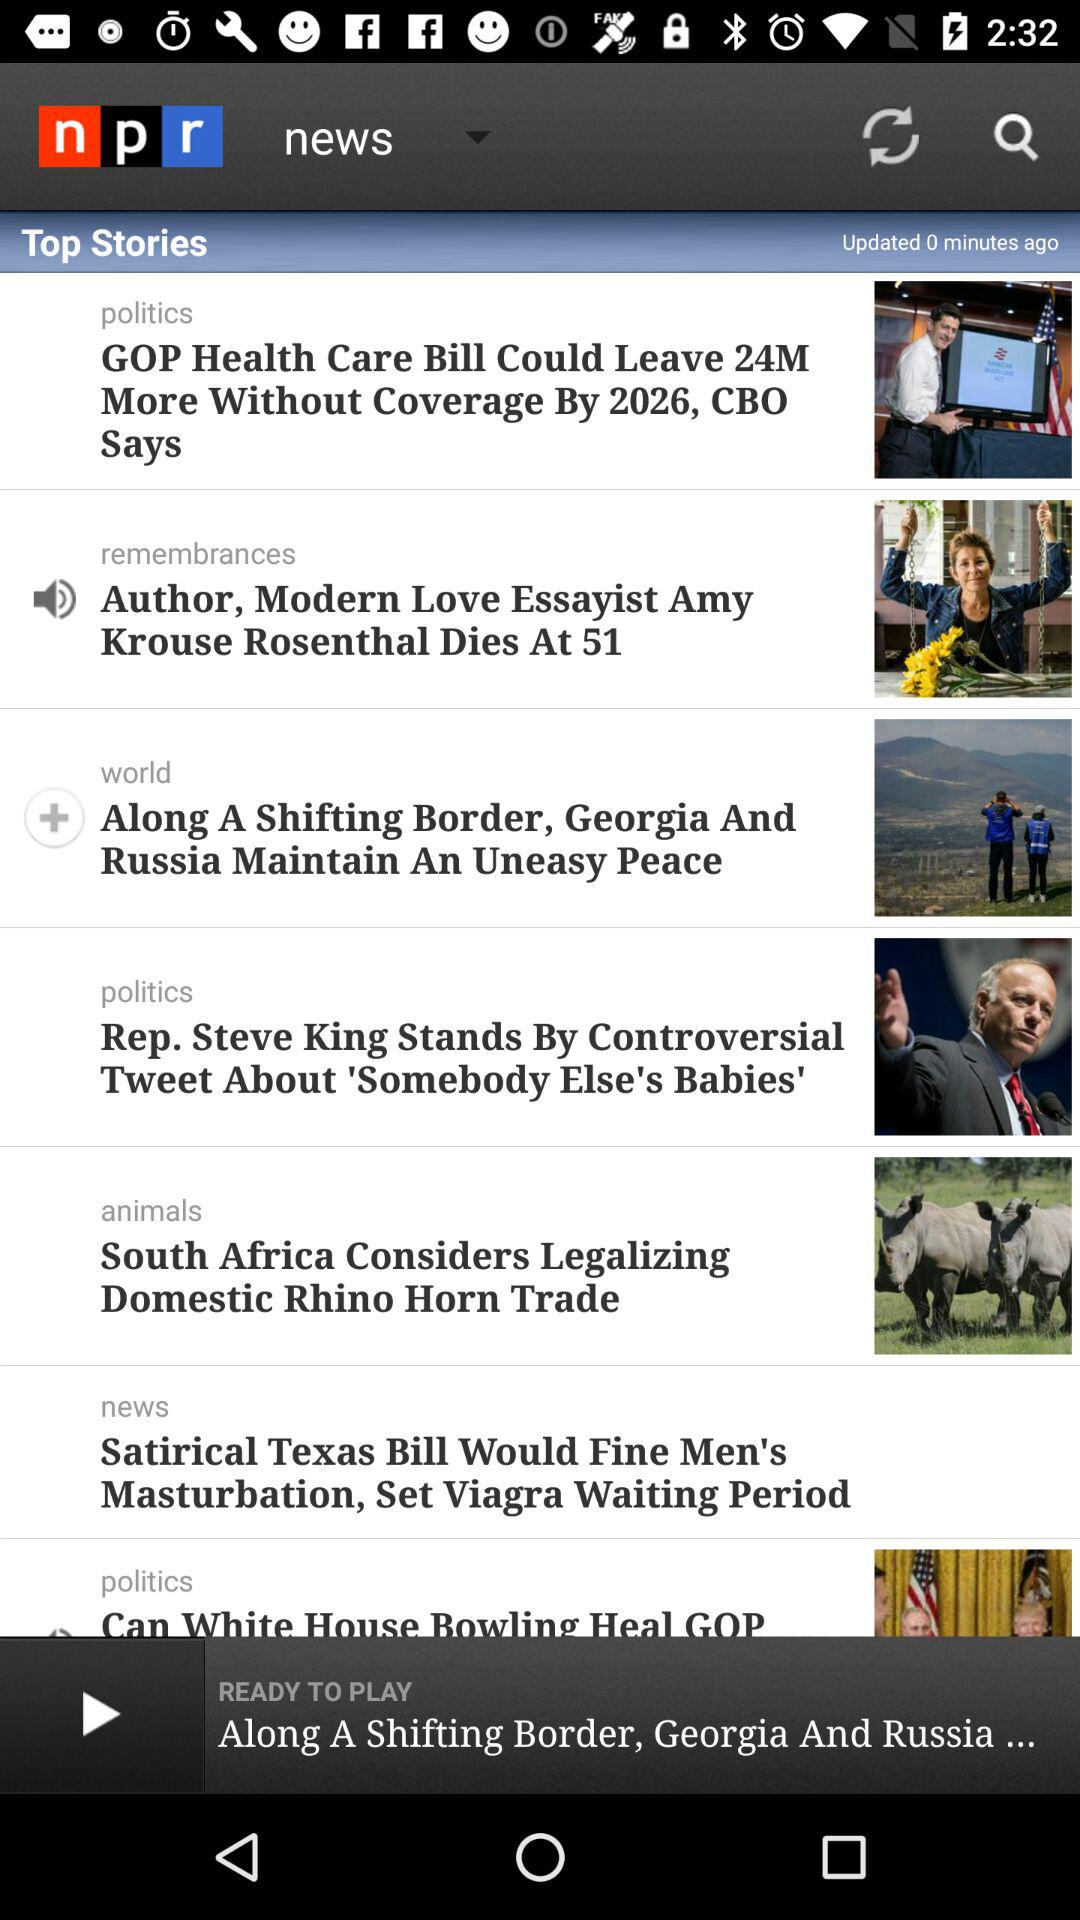How many stories are about politics?
Answer the question using a single word or phrase. 3 